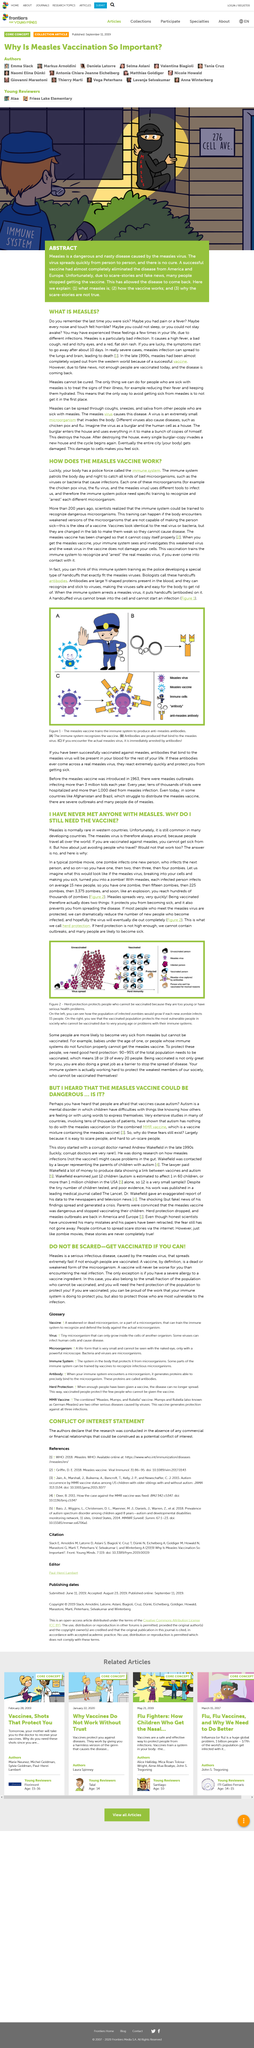Indicate a few pertinent items in this graphic. The human body has a police force charged with maintaining its health and defending it against harmful foreign substances. This police force is known as the immune system. Scientists refer to the handcuffs that stop a disease in its tracks as antibodies. The measles vaccine works by stimulating the immune system to produce antibodies against the measles virus, preparing the body to defend itself against the disease if it is ever exposed to it. The article discusses a severe infection called measles, which is considered to be particularly bad. This article is about the measles vaccine, which is a topic of interest to many individuals. 